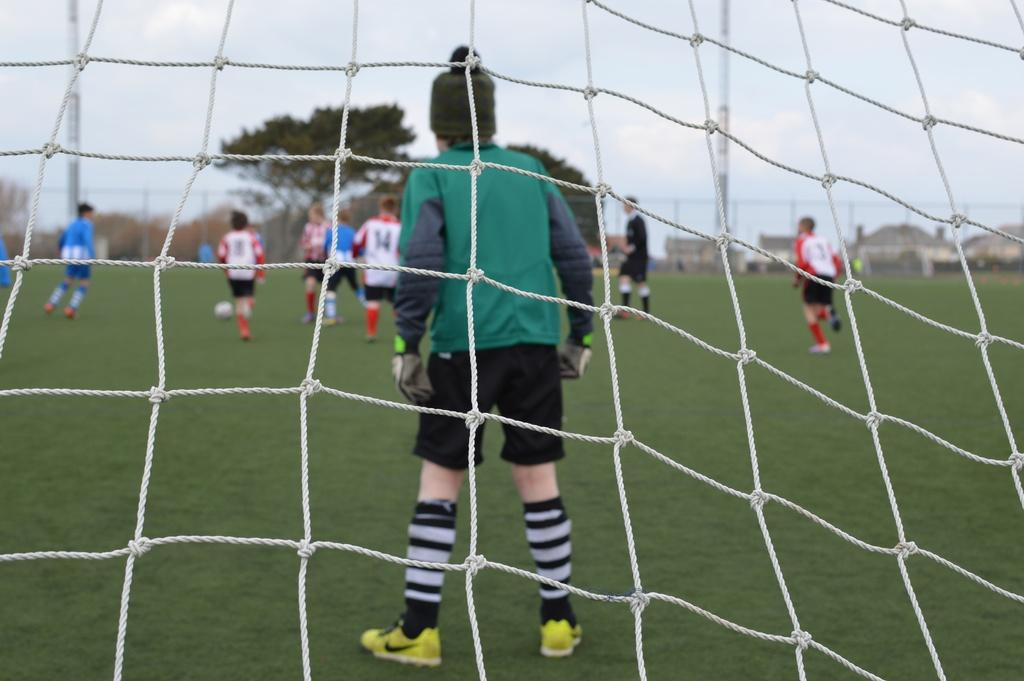<image>
Give a short and clear explanation of the subsequent image. People playing soccer on a field including one wearing jersey number 14. 